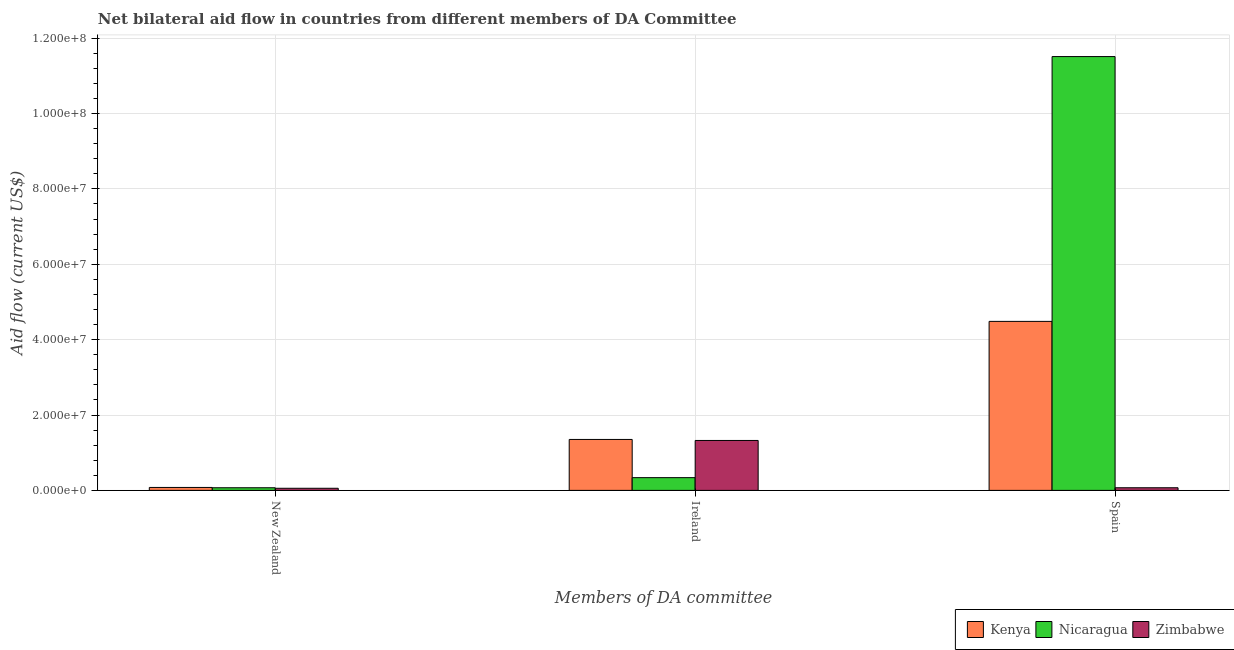How many groups of bars are there?
Ensure brevity in your answer.  3. How many bars are there on the 2nd tick from the left?
Your response must be concise. 3. What is the label of the 1st group of bars from the left?
Offer a very short reply. New Zealand. What is the amount of aid provided by spain in Nicaragua?
Give a very brief answer. 1.15e+08. Across all countries, what is the maximum amount of aid provided by spain?
Keep it short and to the point. 1.15e+08. Across all countries, what is the minimum amount of aid provided by ireland?
Make the answer very short. 3.38e+06. In which country was the amount of aid provided by ireland maximum?
Offer a very short reply. Kenya. In which country was the amount of aid provided by ireland minimum?
Provide a succinct answer. Nicaragua. What is the total amount of aid provided by ireland in the graph?
Your answer should be compact. 3.02e+07. What is the difference between the amount of aid provided by spain in Nicaragua and that in Zimbabwe?
Provide a succinct answer. 1.14e+08. What is the difference between the amount of aid provided by ireland in Zimbabwe and the amount of aid provided by spain in Nicaragua?
Offer a terse response. -1.02e+08. What is the average amount of aid provided by new zealand per country?
Keep it short and to the point. 6.80e+05. What is the difference between the amount of aid provided by spain and amount of aid provided by ireland in Zimbabwe?
Your answer should be very brief. -1.26e+07. In how many countries, is the amount of aid provided by new zealand greater than 76000000 US$?
Offer a terse response. 0. What is the ratio of the amount of aid provided by spain in Zimbabwe to that in Nicaragua?
Give a very brief answer. 0.01. Is the difference between the amount of aid provided by new zealand in Kenya and Nicaragua greater than the difference between the amount of aid provided by ireland in Kenya and Nicaragua?
Make the answer very short. No. What is the difference between the highest and the second highest amount of aid provided by spain?
Provide a succinct answer. 7.03e+07. What is the difference between the highest and the lowest amount of aid provided by ireland?
Ensure brevity in your answer.  1.01e+07. In how many countries, is the amount of aid provided by new zealand greater than the average amount of aid provided by new zealand taken over all countries?
Ensure brevity in your answer.  2. What does the 2nd bar from the left in Spain represents?
Offer a terse response. Nicaragua. What does the 3rd bar from the right in Ireland represents?
Ensure brevity in your answer.  Kenya. Is it the case that in every country, the sum of the amount of aid provided by new zealand and amount of aid provided by ireland is greater than the amount of aid provided by spain?
Offer a terse response. No. How many bars are there?
Offer a very short reply. 9. Are all the bars in the graph horizontal?
Keep it short and to the point. No. What is the difference between two consecutive major ticks on the Y-axis?
Give a very brief answer. 2.00e+07. How are the legend labels stacked?
Offer a very short reply. Horizontal. What is the title of the graph?
Your response must be concise. Net bilateral aid flow in countries from different members of DA Committee. What is the label or title of the X-axis?
Ensure brevity in your answer.  Members of DA committee. What is the Aid flow (current US$) in Kenya in New Zealand?
Give a very brief answer. 7.80e+05. What is the Aid flow (current US$) of Zimbabwe in New Zealand?
Provide a short and direct response. 5.60e+05. What is the Aid flow (current US$) of Kenya in Ireland?
Your answer should be very brief. 1.35e+07. What is the Aid flow (current US$) of Nicaragua in Ireland?
Give a very brief answer. 3.38e+06. What is the Aid flow (current US$) of Zimbabwe in Ireland?
Give a very brief answer. 1.32e+07. What is the Aid flow (current US$) in Kenya in Spain?
Offer a terse response. 4.48e+07. What is the Aid flow (current US$) of Nicaragua in Spain?
Make the answer very short. 1.15e+08. What is the Aid flow (current US$) in Zimbabwe in Spain?
Your answer should be compact. 7.00e+05. Across all Members of DA committee, what is the maximum Aid flow (current US$) in Kenya?
Offer a terse response. 4.48e+07. Across all Members of DA committee, what is the maximum Aid flow (current US$) in Nicaragua?
Offer a terse response. 1.15e+08. Across all Members of DA committee, what is the maximum Aid flow (current US$) of Zimbabwe?
Your answer should be very brief. 1.32e+07. Across all Members of DA committee, what is the minimum Aid flow (current US$) in Kenya?
Offer a terse response. 7.80e+05. Across all Members of DA committee, what is the minimum Aid flow (current US$) of Zimbabwe?
Your answer should be compact. 5.60e+05. What is the total Aid flow (current US$) of Kenya in the graph?
Ensure brevity in your answer.  5.92e+07. What is the total Aid flow (current US$) in Nicaragua in the graph?
Keep it short and to the point. 1.19e+08. What is the total Aid flow (current US$) of Zimbabwe in the graph?
Give a very brief answer. 1.45e+07. What is the difference between the Aid flow (current US$) in Kenya in New Zealand and that in Ireland?
Your response must be concise. -1.27e+07. What is the difference between the Aid flow (current US$) of Nicaragua in New Zealand and that in Ireland?
Offer a very short reply. -2.68e+06. What is the difference between the Aid flow (current US$) in Zimbabwe in New Zealand and that in Ireland?
Make the answer very short. -1.27e+07. What is the difference between the Aid flow (current US$) in Kenya in New Zealand and that in Spain?
Ensure brevity in your answer.  -4.41e+07. What is the difference between the Aid flow (current US$) of Nicaragua in New Zealand and that in Spain?
Offer a terse response. -1.14e+08. What is the difference between the Aid flow (current US$) in Kenya in Ireland and that in Spain?
Provide a short and direct response. -3.13e+07. What is the difference between the Aid flow (current US$) of Nicaragua in Ireland and that in Spain?
Offer a terse response. -1.12e+08. What is the difference between the Aid flow (current US$) of Zimbabwe in Ireland and that in Spain?
Provide a short and direct response. 1.26e+07. What is the difference between the Aid flow (current US$) of Kenya in New Zealand and the Aid flow (current US$) of Nicaragua in Ireland?
Make the answer very short. -2.60e+06. What is the difference between the Aid flow (current US$) in Kenya in New Zealand and the Aid flow (current US$) in Zimbabwe in Ireland?
Your answer should be compact. -1.25e+07. What is the difference between the Aid flow (current US$) in Nicaragua in New Zealand and the Aid flow (current US$) in Zimbabwe in Ireland?
Your answer should be compact. -1.26e+07. What is the difference between the Aid flow (current US$) in Kenya in New Zealand and the Aid flow (current US$) in Nicaragua in Spain?
Your answer should be compact. -1.14e+08. What is the difference between the Aid flow (current US$) of Kenya in New Zealand and the Aid flow (current US$) of Zimbabwe in Spain?
Provide a short and direct response. 8.00e+04. What is the difference between the Aid flow (current US$) in Kenya in Ireland and the Aid flow (current US$) in Nicaragua in Spain?
Your answer should be compact. -1.02e+08. What is the difference between the Aid flow (current US$) of Kenya in Ireland and the Aid flow (current US$) of Zimbabwe in Spain?
Make the answer very short. 1.28e+07. What is the difference between the Aid flow (current US$) of Nicaragua in Ireland and the Aid flow (current US$) of Zimbabwe in Spain?
Your response must be concise. 2.68e+06. What is the average Aid flow (current US$) in Kenya per Members of DA committee?
Provide a succinct answer. 1.97e+07. What is the average Aid flow (current US$) in Nicaragua per Members of DA committee?
Offer a terse response. 3.97e+07. What is the average Aid flow (current US$) of Zimbabwe per Members of DA committee?
Provide a succinct answer. 4.84e+06. What is the difference between the Aid flow (current US$) in Nicaragua and Aid flow (current US$) in Zimbabwe in New Zealand?
Your response must be concise. 1.40e+05. What is the difference between the Aid flow (current US$) of Kenya and Aid flow (current US$) of Nicaragua in Ireland?
Provide a succinct answer. 1.01e+07. What is the difference between the Aid flow (current US$) of Kenya and Aid flow (current US$) of Zimbabwe in Ireland?
Make the answer very short. 2.70e+05. What is the difference between the Aid flow (current US$) of Nicaragua and Aid flow (current US$) of Zimbabwe in Ireland?
Your response must be concise. -9.87e+06. What is the difference between the Aid flow (current US$) in Kenya and Aid flow (current US$) in Nicaragua in Spain?
Make the answer very short. -7.03e+07. What is the difference between the Aid flow (current US$) in Kenya and Aid flow (current US$) in Zimbabwe in Spain?
Provide a short and direct response. 4.42e+07. What is the difference between the Aid flow (current US$) of Nicaragua and Aid flow (current US$) of Zimbabwe in Spain?
Keep it short and to the point. 1.14e+08. What is the ratio of the Aid flow (current US$) in Kenya in New Zealand to that in Ireland?
Offer a very short reply. 0.06. What is the ratio of the Aid flow (current US$) in Nicaragua in New Zealand to that in Ireland?
Keep it short and to the point. 0.21. What is the ratio of the Aid flow (current US$) in Zimbabwe in New Zealand to that in Ireland?
Your answer should be very brief. 0.04. What is the ratio of the Aid flow (current US$) in Kenya in New Zealand to that in Spain?
Provide a short and direct response. 0.02. What is the ratio of the Aid flow (current US$) of Nicaragua in New Zealand to that in Spain?
Keep it short and to the point. 0.01. What is the ratio of the Aid flow (current US$) in Kenya in Ireland to that in Spain?
Provide a succinct answer. 0.3. What is the ratio of the Aid flow (current US$) of Nicaragua in Ireland to that in Spain?
Offer a very short reply. 0.03. What is the ratio of the Aid flow (current US$) of Zimbabwe in Ireland to that in Spain?
Your answer should be compact. 18.93. What is the difference between the highest and the second highest Aid flow (current US$) of Kenya?
Ensure brevity in your answer.  3.13e+07. What is the difference between the highest and the second highest Aid flow (current US$) in Nicaragua?
Keep it short and to the point. 1.12e+08. What is the difference between the highest and the second highest Aid flow (current US$) in Zimbabwe?
Provide a short and direct response. 1.26e+07. What is the difference between the highest and the lowest Aid flow (current US$) in Kenya?
Give a very brief answer. 4.41e+07. What is the difference between the highest and the lowest Aid flow (current US$) in Nicaragua?
Your response must be concise. 1.14e+08. What is the difference between the highest and the lowest Aid flow (current US$) in Zimbabwe?
Make the answer very short. 1.27e+07. 